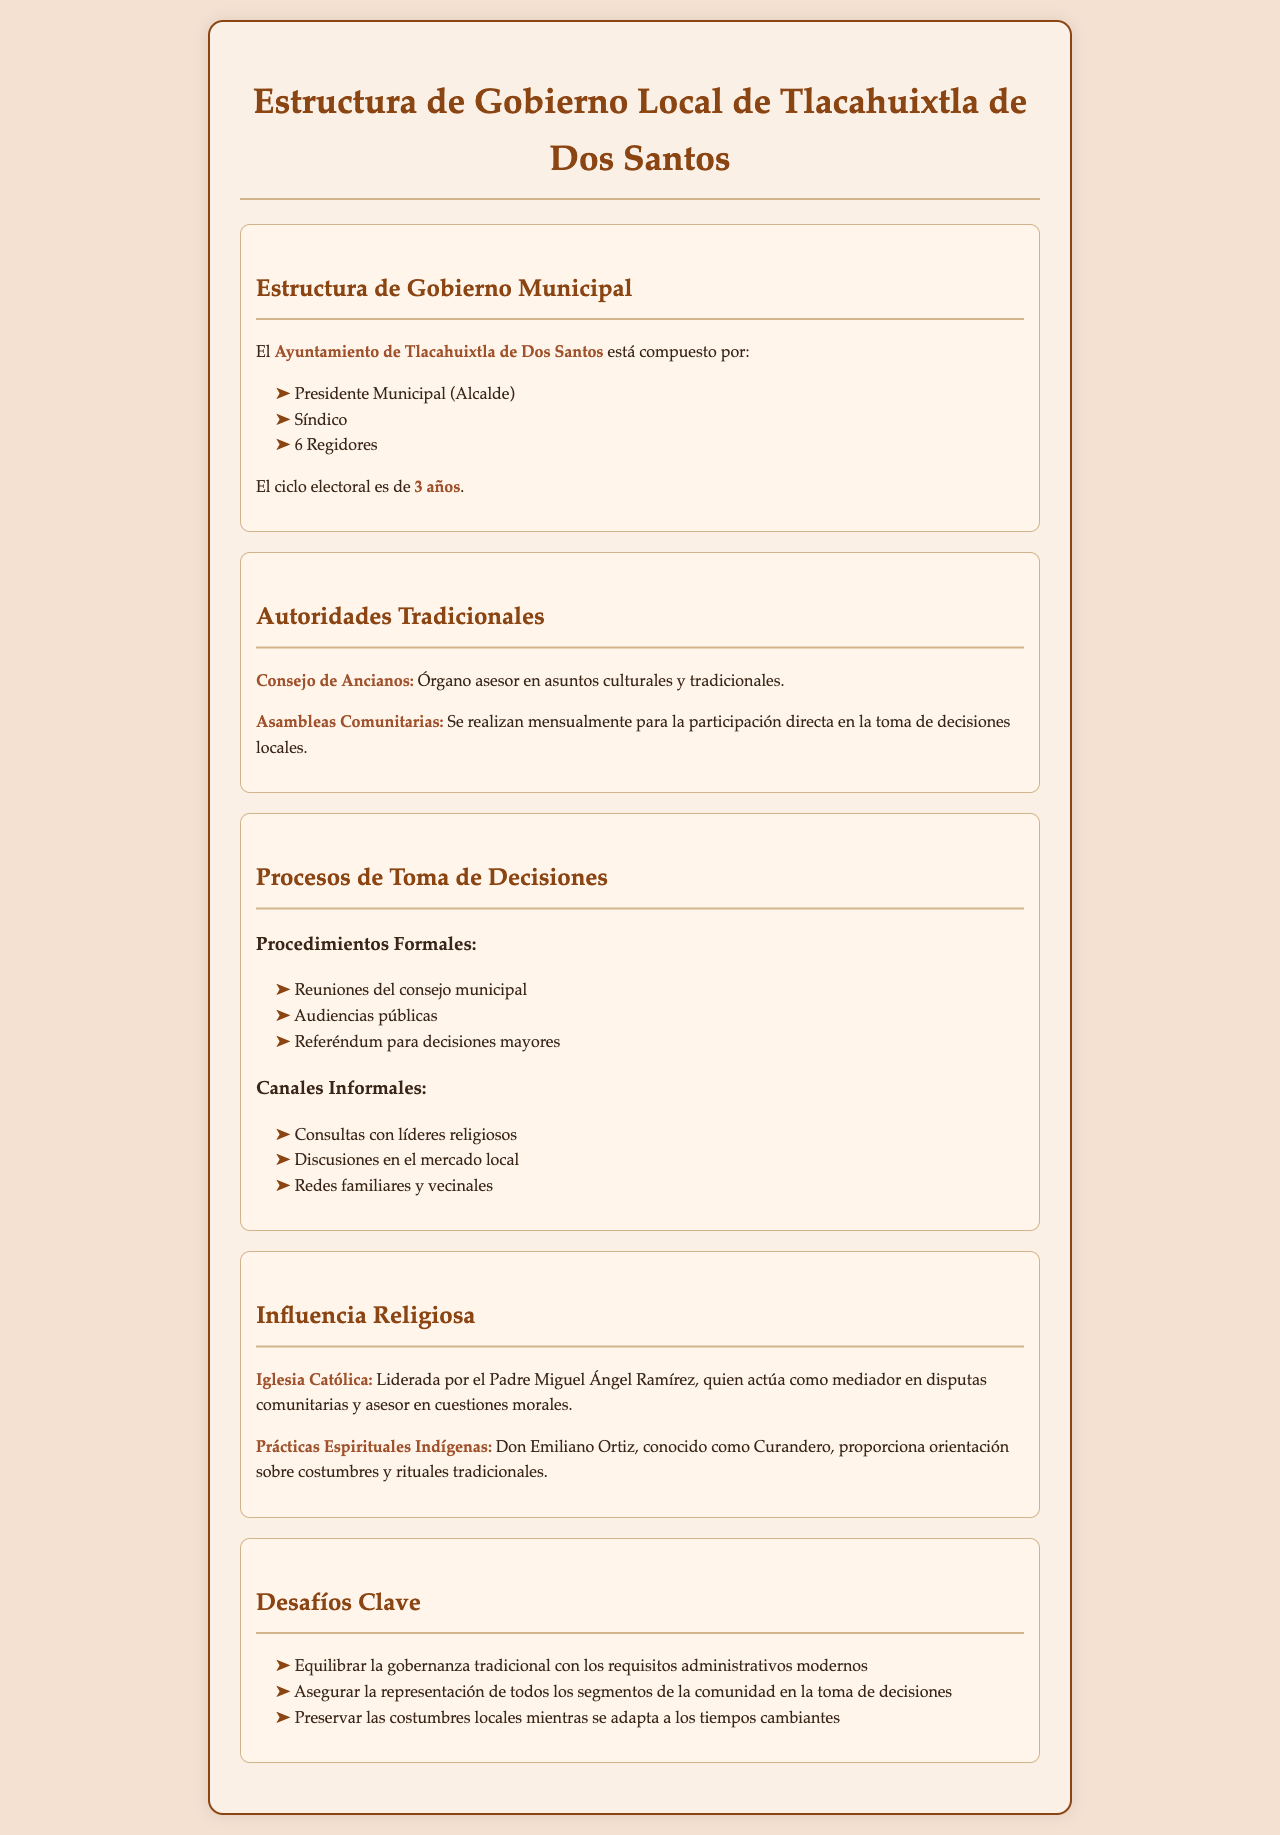¿Cuántos regidores componen el Ayuntamiento de Tlacahuixtla de Dos Santos? El Ayuntamiento está compuesto por 6 regidores, como se menciona en la sección de Estructura de Gobierno Municipal.
Answer: 6 Regidores ¿Quién actúa como mediador en disputas comunitarias? El Padre Miguel Ángel Ramírez es mencionado como el mediador en disputas comunitarias en la sección de Influencia Religiosa.
Answer: Padre Miguel Ángel Ramírez ¿Cuál es el ciclo electoral del Ayuntamiento? Se indica que el ciclo electoral es de 3 años en la sección de Estructura de Gobierno Municipal.
Answer: 3 años ¿Qué órgano sirve como asesor en asuntos culturales y tradicionales? El Consejo de Ancianos es descrito como un órgano asesor en la sección de Autoridades Tradicionales.
Answer: Consejo de Ancianos ¿Cuáles son los procedimientos formales para la toma de decisiones? Los procedimientos formales incluyen reuniones del consejo municipal y audiencias públicas, mencionados en la sección de Procesos de Toma de Decisiones.
Answer: Reuniones del consejo municipal, audiencias públicas ¿Qué desafío clave implica la gobernanza tradicional? Se menciona que un desafío clave es equilibrar la gobernanza tradicional con los requisitos administrativos modernos en la sección de Desafíos Clave.
Answer: Equilibrar la gobernanza tradicional ¿Qué tipo de consultas son canales informales en la toma de decisiones? Se mencionan consultas con líderes religiosos y discusiones en el mercado local como canales informales en la sección de Procesos de Toma de Decisiones.
Answer: Consultas con líderes religiosos, discusiones en el mercado local ¿Quién es conocido como Curandero en la comunidad? Don Emiliano Ortiz es mencionado como el Curandero que proporciona orientación sobre costumbres y rituales en la sección de Influencia Religiosa.
Answer: Don Emiliano Ortiz 